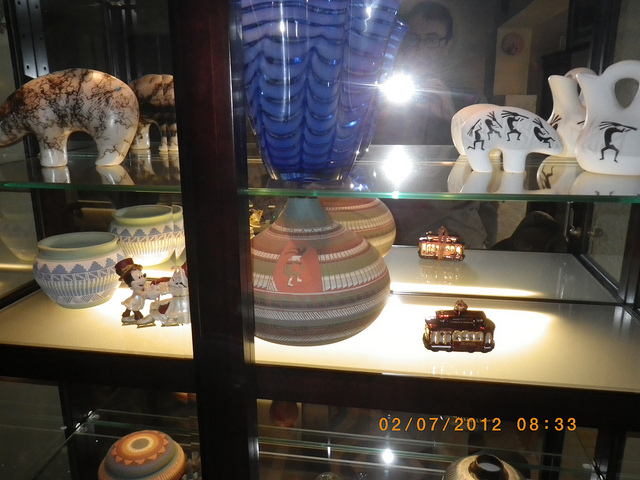<image>How many antiques are there? I don't know how many antiques are there. The number might vary. How many antiques are there? It is unanswerable how many antiques are there. 